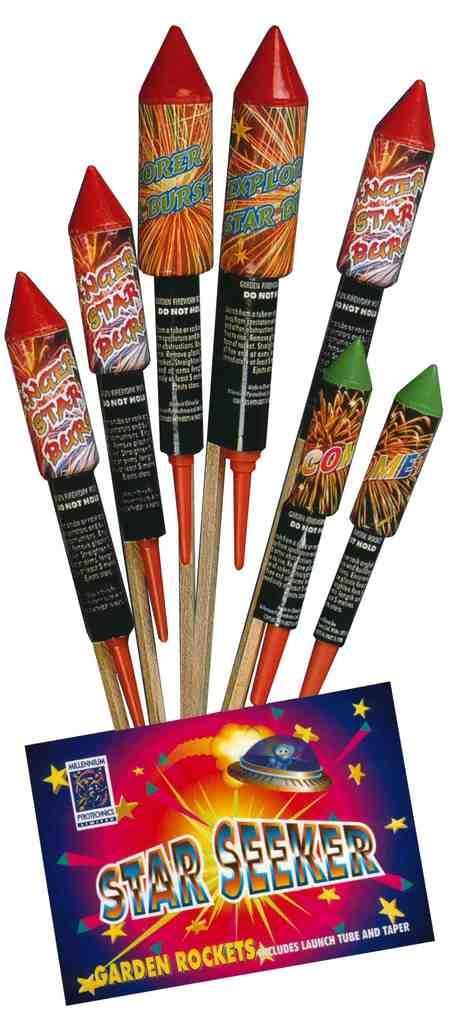Please provide a concise description of this image. In this image there are crackers at the bottom there is a sticker, on that there is some text. 